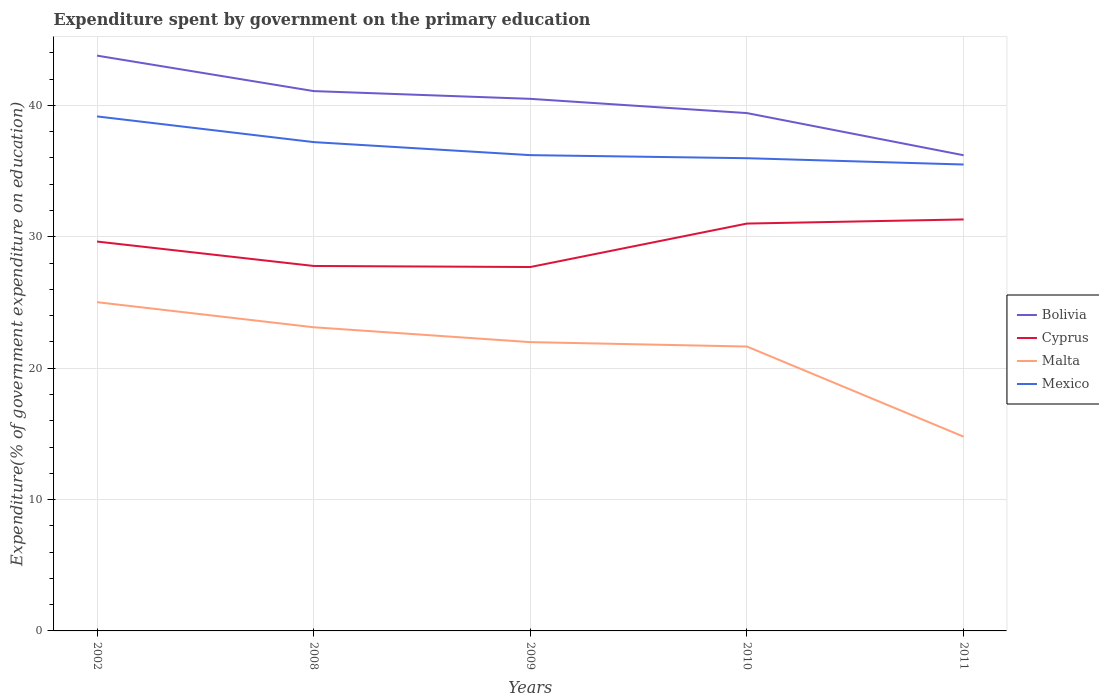Across all years, what is the maximum expenditure spent by government on the primary education in Bolivia?
Provide a short and direct response. 36.21. What is the total expenditure spent by government on the primary education in Cyprus in the graph?
Make the answer very short. -3.62. What is the difference between the highest and the second highest expenditure spent by government on the primary education in Malta?
Offer a terse response. 10.24. What is the difference between the highest and the lowest expenditure spent by government on the primary education in Malta?
Your answer should be compact. 4. How many lines are there?
Ensure brevity in your answer.  4. What is the difference between two consecutive major ticks on the Y-axis?
Give a very brief answer. 10. Does the graph contain any zero values?
Offer a very short reply. No. Does the graph contain grids?
Your answer should be very brief. Yes. Where does the legend appear in the graph?
Your response must be concise. Center right. How many legend labels are there?
Give a very brief answer. 4. What is the title of the graph?
Make the answer very short. Expenditure spent by government on the primary education. Does "Luxembourg" appear as one of the legend labels in the graph?
Offer a very short reply. No. What is the label or title of the Y-axis?
Make the answer very short. Expenditure(% of government expenditure on education). What is the Expenditure(% of government expenditure on education) in Bolivia in 2002?
Ensure brevity in your answer.  43.79. What is the Expenditure(% of government expenditure on education) of Cyprus in 2002?
Give a very brief answer. 29.64. What is the Expenditure(% of government expenditure on education) in Malta in 2002?
Your response must be concise. 25.02. What is the Expenditure(% of government expenditure on education) of Mexico in 2002?
Ensure brevity in your answer.  39.16. What is the Expenditure(% of government expenditure on education) in Bolivia in 2008?
Provide a succinct answer. 41.09. What is the Expenditure(% of government expenditure on education) of Cyprus in 2008?
Make the answer very short. 27.78. What is the Expenditure(% of government expenditure on education) of Malta in 2008?
Give a very brief answer. 23.11. What is the Expenditure(% of government expenditure on education) of Mexico in 2008?
Provide a succinct answer. 37.21. What is the Expenditure(% of government expenditure on education) in Bolivia in 2009?
Give a very brief answer. 40.5. What is the Expenditure(% of government expenditure on education) in Cyprus in 2009?
Your answer should be compact. 27.7. What is the Expenditure(% of government expenditure on education) of Malta in 2009?
Ensure brevity in your answer.  21.98. What is the Expenditure(% of government expenditure on education) in Mexico in 2009?
Make the answer very short. 36.22. What is the Expenditure(% of government expenditure on education) in Bolivia in 2010?
Your answer should be very brief. 39.42. What is the Expenditure(% of government expenditure on education) in Cyprus in 2010?
Your response must be concise. 31.01. What is the Expenditure(% of government expenditure on education) in Malta in 2010?
Your answer should be very brief. 21.65. What is the Expenditure(% of government expenditure on education) of Mexico in 2010?
Offer a terse response. 35.98. What is the Expenditure(% of government expenditure on education) of Bolivia in 2011?
Make the answer very short. 36.21. What is the Expenditure(% of government expenditure on education) in Cyprus in 2011?
Provide a short and direct response. 31.32. What is the Expenditure(% of government expenditure on education) of Malta in 2011?
Give a very brief answer. 14.79. What is the Expenditure(% of government expenditure on education) in Mexico in 2011?
Give a very brief answer. 35.5. Across all years, what is the maximum Expenditure(% of government expenditure on education) in Bolivia?
Provide a succinct answer. 43.79. Across all years, what is the maximum Expenditure(% of government expenditure on education) in Cyprus?
Your answer should be very brief. 31.32. Across all years, what is the maximum Expenditure(% of government expenditure on education) in Malta?
Offer a terse response. 25.02. Across all years, what is the maximum Expenditure(% of government expenditure on education) of Mexico?
Ensure brevity in your answer.  39.16. Across all years, what is the minimum Expenditure(% of government expenditure on education) of Bolivia?
Offer a very short reply. 36.21. Across all years, what is the minimum Expenditure(% of government expenditure on education) in Cyprus?
Your answer should be very brief. 27.7. Across all years, what is the minimum Expenditure(% of government expenditure on education) in Malta?
Offer a terse response. 14.79. Across all years, what is the minimum Expenditure(% of government expenditure on education) in Mexico?
Your answer should be compact. 35.5. What is the total Expenditure(% of government expenditure on education) in Bolivia in the graph?
Your answer should be compact. 201.01. What is the total Expenditure(% of government expenditure on education) of Cyprus in the graph?
Provide a short and direct response. 147.45. What is the total Expenditure(% of government expenditure on education) in Malta in the graph?
Your answer should be very brief. 106.56. What is the total Expenditure(% of government expenditure on education) of Mexico in the graph?
Give a very brief answer. 184.08. What is the difference between the Expenditure(% of government expenditure on education) of Cyprus in 2002 and that in 2008?
Offer a very short reply. 1.86. What is the difference between the Expenditure(% of government expenditure on education) of Malta in 2002 and that in 2008?
Provide a succinct answer. 1.91. What is the difference between the Expenditure(% of government expenditure on education) of Mexico in 2002 and that in 2008?
Give a very brief answer. 1.96. What is the difference between the Expenditure(% of government expenditure on education) of Bolivia in 2002 and that in 2009?
Provide a succinct answer. 3.29. What is the difference between the Expenditure(% of government expenditure on education) in Cyprus in 2002 and that in 2009?
Make the answer very short. 1.94. What is the difference between the Expenditure(% of government expenditure on education) of Malta in 2002 and that in 2009?
Ensure brevity in your answer.  3.04. What is the difference between the Expenditure(% of government expenditure on education) in Mexico in 2002 and that in 2009?
Your answer should be compact. 2.95. What is the difference between the Expenditure(% of government expenditure on education) in Bolivia in 2002 and that in 2010?
Ensure brevity in your answer.  4.37. What is the difference between the Expenditure(% of government expenditure on education) of Cyprus in 2002 and that in 2010?
Your answer should be compact. -1.37. What is the difference between the Expenditure(% of government expenditure on education) of Malta in 2002 and that in 2010?
Provide a succinct answer. 3.38. What is the difference between the Expenditure(% of government expenditure on education) in Mexico in 2002 and that in 2010?
Your answer should be very brief. 3.18. What is the difference between the Expenditure(% of government expenditure on education) in Bolivia in 2002 and that in 2011?
Your answer should be compact. 7.58. What is the difference between the Expenditure(% of government expenditure on education) of Cyprus in 2002 and that in 2011?
Provide a succinct answer. -1.68. What is the difference between the Expenditure(% of government expenditure on education) of Malta in 2002 and that in 2011?
Keep it short and to the point. 10.24. What is the difference between the Expenditure(% of government expenditure on education) in Mexico in 2002 and that in 2011?
Give a very brief answer. 3.66. What is the difference between the Expenditure(% of government expenditure on education) in Bolivia in 2008 and that in 2009?
Make the answer very short. 0.59. What is the difference between the Expenditure(% of government expenditure on education) in Cyprus in 2008 and that in 2009?
Your answer should be very brief. 0.08. What is the difference between the Expenditure(% of government expenditure on education) in Malta in 2008 and that in 2009?
Offer a very short reply. 1.13. What is the difference between the Expenditure(% of government expenditure on education) of Bolivia in 2008 and that in 2010?
Your answer should be compact. 1.67. What is the difference between the Expenditure(% of government expenditure on education) of Cyprus in 2008 and that in 2010?
Your answer should be compact. -3.23. What is the difference between the Expenditure(% of government expenditure on education) of Malta in 2008 and that in 2010?
Make the answer very short. 1.47. What is the difference between the Expenditure(% of government expenditure on education) in Mexico in 2008 and that in 2010?
Your answer should be very brief. 1.22. What is the difference between the Expenditure(% of government expenditure on education) in Bolivia in 2008 and that in 2011?
Ensure brevity in your answer.  4.88. What is the difference between the Expenditure(% of government expenditure on education) of Cyprus in 2008 and that in 2011?
Your answer should be compact. -3.54. What is the difference between the Expenditure(% of government expenditure on education) of Malta in 2008 and that in 2011?
Your response must be concise. 8.33. What is the difference between the Expenditure(% of government expenditure on education) of Mexico in 2008 and that in 2011?
Your answer should be compact. 1.71. What is the difference between the Expenditure(% of government expenditure on education) in Bolivia in 2009 and that in 2010?
Your answer should be very brief. 1.08. What is the difference between the Expenditure(% of government expenditure on education) of Cyprus in 2009 and that in 2010?
Your answer should be very brief. -3.31. What is the difference between the Expenditure(% of government expenditure on education) of Malta in 2009 and that in 2010?
Offer a very short reply. 0.34. What is the difference between the Expenditure(% of government expenditure on education) in Mexico in 2009 and that in 2010?
Offer a very short reply. 0.23. What is the difference between the Expenditure(% of government expenditure on education) of Bolivia in 2009 and that in 2011?
Your answer should be compact. 4.29. What is the difference between the Expenditure(% of government expenditure on education) in Cyprus in 2009 and that in 2011?
Give a very brief answer. -3.62. What is the difference between the Expenditure(% of government expenditure on education) in Malta in 2009 and that in 2011?
Your answer should be compact. 7.2. What is the difference between the Expenditure(% of government expenditure on education) of Mexico in 2009 and that in 2011?
Make the answer very short. 0.71. What is the difference between the Expenditure(% of government expenditure on education) of Bolivia in 2010 and that in 2011?
Your response must be concise. 3.21. What is the difference between the Expenditure(% of government expenditure on education) of Cyprus in 2010 and that in 2011?
Give a very brief answer. -0.31. What is the difference between the Expenditure(% of government expenditure on education) of Malta in 2010 and that in 2011?
Make the answer very short. 6.86. What is the difference between the Expenditure(% of government expenditure on education) of Mexico in 2010 and that in 2011?
Your answer should be very brief. 0.48. What is the difference between the Expenditure(% of government expenditure on education) in Bolivia in 2002 and the Expenditure(% of government expenditure on education) in Cyprus in 2008?
Keep it short and to the point. 16.01. What is the difference between the Expenditure(% of government expenditure on education) in Bolivia in 2002 and the Expenditure(% of government expenditure on education) in Malta in 2008?
Ensure brevity in your answer.  20.68. What is the difference between the Expenditure(% of government expenditure on education) of Bolivia in 2002 and the Expenditure(% of government expenditure on education) of Mexico in 2008?
Make the answer very short. 6.58. What is the difference between the Expenditure(% of government expenditure on education) of Cyprus in 2002 and the Expenditure(% of government expenditure on education) of Malta in 2008?
Make the answer very short. 6.52. What is the difference between the Expenditure(% of government expenditure on education) of Cyprus in 2002 and the Expenditure(% of government expenditure on education) of Mexico in 2008?
Ensure brevity in your answer.  -7.57. What is the difference between the Expenditure(% of government expenditure on education) of Malta in 2002 and the Expenditure(% of government expenditure on education) of Mexico in 2008?
Ensure brevity in your answer.  -12.18. What is the difference between the Expenditure(% of government expenditure on education) of Bolivia in 2002 and the Expenditure(% of government expenditure on education) of Cyprus in 2009?
Make the answer very short. 16.09. What is the difference between the Expenditure(% of government expenditure on education) of Bolivia in 2002 and the Expenditure(% of government expenditure on education) of Malta in 2009?
Keep it short and to the point. 21.81. What is the difference between the Expenditure(% of government expenditure on education) in Bolivia in 2002 and the Expenditure(% of government expenditure on education) in Mexico in 2009?
Your answer should be compact. 7.58. What is the difference between the Expenditure(% of government expenditure on education) in Cyprus in 2002 and the Expenditure(% of government expenditure on education) in Malta in 2009?
Your answer should be very brief. 7.66. What is the difference between the Expenditure(% of government expenditure on education) of Cyprus in 2002 and the Expenditure(% of government expenditure on education) of Mexico in 2009?
Offer a very short reply. -6.58. What is the difference between the Expenditure(% of government expenditure on education) in Malta in 2002 and the Expenditure(% of government expenditure on education) in Mexico in 2009?
Provide a short and direct response. -11.19. What is the difference between the Expenditure(% of government expenditure on education) of Bolivia in 2002 and the Expenditure(% of government expenditure on education) of Cyprus in 2010?
Your answer should be very brief. 12.78. What is the difference between the Expenditure(% of government expenditure on education) of Bolivia in 2002 and the Expenditure(% of government expenditure on education) of Malta in 2010?
Offer a terse response. 22.14. What is the difference between the Expenditure(% of government expenditure on education) of Bolivia in 2002 and the Expenditure(% of government expenditure on education) of Mexico in 2010?
Ensure brevity in your answer.  7.81. What is the difference between the Expenditure(% of government expenditure on education) of Cyprus in 2002 and the Expenditure(% of government expenditure on education) of Malta in 2010?
Make the answer very short. 7.99. What is the difference between the Expenditure(% of government expenditure on education) in Cyprus in 2002 and the Expenditure(% of government expenditure on education) in Mexico in 2010?
Provide a succinct answer. -6.34. What is the difference between the Expenditure(% of government expenditure on education) in Malta in 2002 and the Expenditure(% of government expenditure on education) in Mexico in 2010?
Your answer should be compact. -10.96. What is the difference between the Expenditure(% of government expenditure on education) in Bolivia in 2002 and the Expenditure(% of government expenditure on education) in Cyprus in 2011?
Your answer should be very brief. 12.47. What is the difference between the Expenditure(% of government expenditure on education) in Bolivia in 2002 and the Expenditure(% of government expenditure on education) in Malta in 2011?
Make the answer very short. 29. What is the difference between the Expenditure(% of government expenditure on education) of Bolivia in 2002 and the Expenditure(% of government expenditure on education) of Mexico in 2011?
Ensure brevity in your answer.  8.29. What is the difference between the Expenditure(% of government expenditure on education) in Cyprus in 2002 and the Expenditure(% of government expenditure on education) in Malta in 2011?
Your answer should be compact. 14.85. What is the difference between the Expenditure(% of government expenditure on education) of Cyprus in 2002 and the Expenditure(% of government expenditure on education) of Mexico in 2011?
Make the answer very short. -5.86. What is the difference between the Expenditure(% of government expenditure on education) in Malta in 2002 and the Expenditure(% of government expenditure on education) in Mexico in 2011?
Provide a succinct answer. -10.48. What is the difference between the Expenditure(% of government expenditure on education) of Bolivia in 2008 and the Expenditure(% of government expenditure on education) of Cyprus in 2009?
Ensure brevity in your answer.  13.39. What is the difference between the Expenditure(% of government expenditure on education) of Bolivia in 2008 and the Expenditure(% of government expenditure on education) of Malta in 2009?
Ensure brevity in your answer.  19.11. What is the difference between the Expenditure(% of government expenditure on education) in Bolivia in 2008 and the Expenditure(% of government expenditure on education) in Mexico in 2009?
Offer a very short reply. 4.88. What is the difference between the Expenditure(% of government expenditure on education) of Cyprus in 2008 and the Expenditure(% of government expenditure on education) of Malta in 2009?
Give a very brief answer. 5.8. What is the difference between the Expenditure(% of government expenditure on education) in Cyprus in 2008 and the Expenditure(% of government expenditure on education) in Mexico in 2009?
Provide a succinct answer. -8.44. What is the difference between the Expenditure(% of government expenditure on education) of Malta in 2008 and the Expenditure(% of government expenditure on education) of Mexico in 2009?
Offer a very short reply. -13.1. What is the difference between the Expenditure(% of government expenditure on education) in Bolivia in 2008 and the Expenditure(% of government expenditure on education) in Cyprus in 2010?
Keep it short and to the point. 10.08. What is the difference between the Expenditure(% of government expenditure on education) of Bolivia in 2008 and the Expenditure(% of government expenditure on education) of Malta in 2010?
Offer a terse response. 19.44. What is the difference between the Expenditure(% of government expenditure on education) of Bolivia in 2008 and the Expenditure(% of government expenditure on education) of Mexico in 2010?
Make the answer very short. 5.11. What is the difference between the Expenditure(% of government expenditure on education) of Cyprus in 2008 and the Expenditure(% of government expenditure on education) of Malta in 2010?
Provide a short and direct response. 6.13. What is the difference between the Expenditure(% of government expenditure on education) in Cyprus in 2008 and the Expenditure(% of government expenditure on education) in Mexico in 2010?
Provide a succinct answer. -8.2. What is the difference between the Expenditure(% of government expenditure on education) of Malta in 2008 and the Expenditure(% of government expenditure on education) of Mexico in 2010?
Your response must be concise. -12.87. What is the difference between the Expenditure(% of government expenditure on education) in Bolivia in 2008 and the Expenditure(% of government expenditure on education) in Cyprus in 2011?
Ensure brevity in your answer.  9.77. What is the difference between the Expenditure(% of government expenditure on education) in Bolivia in 2008 and the Expenditure(% of government expenditure on education) in Malta in 2011?
Provide a short and direct response. 26.3. What is the difference between the Expenditure(% of government expenditure on education) in Bolivia in 2008 and the Expenditure(% of government expenditure on education) in Mexico in 2011?
Offer a very short reply. 5.59. What is the difference between the Expenditure(% of government expenditure on education) in Cyprus in 2008 and the Expenditure(% of government expenditure on education) in Malta in 2011?
Provide a succinct answer. 12.99. What is the difference between the Expenditure(% of government expenditure on education) of Cyprus in 2008 and the Expenditure(% of government expenditure on education) of Mexico in 2011?
Provide a short and direct response. -7.72. What is the difference between the Expenditure(% of government expenditure on education) in Malta in 2008 and the Expenditure(% of government expenditure on education) in Mexico in 2011?
Offer a terse response. -12.39. What is the difference between the Expenditure(% of government expenditure on education) of Bolivia in 2009 and the Expenditure(% of government expenditure on education) of Cyprus in 2010?
Offer a very short reply. 9.49. What is the difference between the Expenditure(% of government expenditure on education) in Bolivia in 2009 and the Expenditure(% of government expenditure on education) in Malta in 2010?
Keep it short and to the point. 18.85. What is the difference between the Expenditure(% of government expenditure on education) of Bolivia in 2009 and the Expenditure(% of government expenditure on education) of Mexico in 2010?
Your answer should be compact. 4.52. What is the difference between the Expenditure(% of government expenditure on education) in Cyprus in 2009 and the Expenditure(% of government expenditure on education) in Malta in 2010?
Your answer should be very brief. 6.05. What is the difference between the Expenditure(% of government expenditure on education) of Cyprus in 2009 and the Expenditure(% of government expenditure on education) of Mexico in 2010?
Give a very brief answer. -8.28. What is the difference between the Expenditure(% of government expenditure on education) of Malta in 2009 and the Expenditure(% of government expenditure on education) of Mexico in 2010?
Provide a succinct answer. -14. What is the difference between the Expenditure(% of government expenditure on education) in Bolivia in 2009 and the Expenditure(% of government expenditure on education) in Cyprus in 2011?
Keep it short and to the point. 9.18. What is the difference between the Expenditure(% of government expenditure on education) in Bolivia in 2009 and the Expenditure(% of government expenditure on education) in Malta in 2011?
Offer a very short reply. 25.71. What is the difference between the Expenditure(% of government expenditure on education) of Bolivia in 2009 and the Expenditure(% of government expenditure on education) of Mexico in 2011?
Offer a very short reply. 5. What is the difference between the Expenditure(% of government expenditure on education) of Cyprus in 2009 and the Expenditure(% of government expenditure on education) of Malta in 2011?
Offer a very short reply. 12.91. What is the difference between the Expenditure(% of government expenditure on education) of Cyprus in 2009 and the Expenditure(% of government expenditure on education) of Mexico in 2011?
Make the answer very short. -7.8. What is the difference between the Expenditure(% of government expenditure on education) of Malta in 2009 and the Expenditure(% of government expenditure on education) of Mexico in 2011?
Provide a succinct answer. -13.52. What is the difference between the Expenditure(% of government expenditure on education) in Bolivia in 2010 and the Expenditure(% of government expenditure on education) in Cyprus in 2011?
Your answer should be very brief. 8.1. What is the difference between the Expenditure(% of government expenditure on education) in Bolivia in 2010 and the Expenditure(% of government expenditure on education) in Malta in 2011?
Offer a very short reply. 24.63. What is the difference between the Expenditure(% of government expenditure on education) of Bolivia in 2010 and the Expenditure(% of government expenditure on education) of Mexico in 2011?
Ensure brevity in your answer.  3.92. What is the difference between the Expenditure(% of government expenditure on education) of Cyprus in 2010 and the Expenditure(% of government expenditure on education) of Malta in 2011?
Provide a short and direct response. 16.22. What is the difference between the Expenditure(% of government expenditure on education) of Cyprus in 2010 and the Expenditure(% of government expenditure on education) of Mexico in 2011?
Offer a very short reply. -4.49. What is the difference between the Expenditure(% of government expenditure on education) of Malta in 2010 and the Expenditure(% of government expenditure on education) of Mexico in 2011?
Give a very brief answer. -13.85. What is the average Expenditure(% of government expenditure on education) of Bolivia per year?
Your answer should be very brief. 40.2. What is the average Expenditure(% of government expenditure on education) of Cyprus per year?
Offer a very short reply. 29.49. What is the average Expenditure(% of government expenditure on education) in Malta per year?
Provide a succinct answer. 21.31. What is the average Expenditure(% of government expenditure on education) in Mexico per year?
Your answer should be very brief. 36.82. In the year 2002, what is the difference between the Expenditure(% of government expenditure on education) of Bolivia and Expenditure(% of government expenditure on education) of Cyprus?
Your answer should be very brief. 14.15. In the year 2002, what is the difference between the Expenditure(% of government expenditure on education) of Bolivia and Expenditure(% of government expenditure on education) of Malta?
Offer a terse response. 18.77. In the year 2002, what is the difference between the Expenditure(% of government expenditure on education) in Bolivia and Expenditure(% of government expenditure on education) in Mexico?
Provide a succinct answer. 4.63. In the year 2002, what is the difference between the Expenditure(% of government expenditure on education) in Cyprus and Expenditure(% of government expenditure on education) in Malta?
Offer a very short reply. 4.62. In the year 2002, what is the difference between the Expenditure(% of government expenditure on education) in Cyprus and Expenditure(% of government expenditure on education) in Mexico?
Give a very brief answer. -9.53. In the year 2002, what is the difference between the Expenditure(% of government expenditure on education) of Malta and Expenditure(% of government expenditure on education) of Mexico?
Provide a short and direct response. -14.14. In the year 2008, what is the difference between the Expenditure(% of government expenditure on education) in Bolivia and Expenditure(% of government expenditure on education) in Cyprus?
Provide a short and direct response. 13.31. In the year 2008, what is the difference between the Expenditure(% of government expenditure on education) in Bolivia and Expenditure(% of government expenditure on education) in Malta?
Your answer should be compact. 17.98. In the year 2008, what is the difference between the Expenditure(% of government expenditure on education) in Bolivia and Expenditure(% of government expenditure on education) in Mexico?
Your answer should be very brief. 3.88. In the year 2008, what is the difference between the Expenditure(% of government expenditure on education) in Cyprus and Expenditure(% of government expenditure on education) in Malta?
Make the answer very short. 4.67. In the year 2008, what is the difference between the Expenditure(% of government expenditure on education) in Cyprus and Expenditure(% of government expenditure on education) in Mexico?
Give a very brief answer. -9.43. In the year 2008, what is the difference between the Expenditure(% of government expenditure on education) in Malta and Expenditure(% of government expenditure on education) in Mexico?
Your answer should be very brief. -14.09. In the year 2009, what is the difference between the Expenditure(% of government expenditure on education) in Bolivia and Expenditure(% of government expenditure on education) in Cyprus?
Keep it short and to the point. 12.8. In the year 2009, what is the difference between the Expenditure(% of government expenditure on education) in Bolivia and Expenditure(% of government expenditure on education) in Malta?
Offer a very short reply. 18.52. In the year 2009, what is the difference between the Expenditure(% of government expenditure on education) of Bolivia and Expenditure(% of government expenditure on education) of Mexico?
Provide a short and direct response. 4.29. In the year 2009, what is the difference between the Expenditure(% of government expenditure on education) of Cyprus and Expenditure(% of government expenditure on education) of Malta?
Ensure brevity in your answer.  5.72. In the year 2009, what is the difference between the Expenditure(% of government expenditure on education) in Cyprus and Expenditure(% of government expenditure on education) in Mexico?
Provide a short and direct response. -8.52. In the year 2009, what is the difference between the Expenditure(% of government expenditure on education) of Malta and Expenditure(% of government expenditure on education) of Mexico?
Your response must be concise. -14.23. In the year 2010, what is the difference between the Expenditure(% of government expenditure on education) of Bolivia and Expenditure(% of government expenditure on education) of Cyprus?
Your response must be concise. 8.41. In the year 2010, what is the difference between the Expenditure(% of government expenditure on education) of Bolivia and Expenditure(% of government expenditure on education) of Malta?
Keep it short and to the point. 17.77. In the year 2010, what is the difference between the Expenditure(% of government expenditure on education) in Bolivia and Expenditure(% of government expenditure on education) in Mexico?
Provide a succinct answer. 3.43. In the year 2010, what is the difference between the Expenditure(% of government expenditure on education) in Cyprus and Expenditure(% of government expenditure on education) in Malta?
Offer a terse response. 9.36. In the year 2010, what is the difference between the Expenditure(% of government expenditure on education) in Cyprus and Expenditure(% of government expenditure on education) in Mexico?
Provide a short and direct response. -4.98. In the year 2010, what is the difference between the Expenditure(% of government expenditure on education) of Malta and Expenditure(% of government expenditure on education) of Mexico?
Provide a short and direct response. -14.34. In the year 2011, what is the difference between the Expenditure(% of government expenditure on education) in Bolivia and Expenditure(% of government expenditure on education) in Cyprus?
Offer a very short reply. 4.89. In the year 2011, what is the difference between the Expenditure(% of government expenditure on education) of Bolivia and Expenditure(% of government expenditure on education) of Malta?
Provide a succinct answer. 21.42. In the year 2011, what is the difference between the Expenditure(% of government expenditure on education) in Bolivia and Expenditure(% of government expenditure on education) in Mexico?
Provide a short and direct response. 0.71. In the year 2011, what is the difference between the Expenditure(% of government expenditure on education) in Cyprus and Expenditure(% of government expenditure on education) in Malta?
Keep it short and to the point. 16.53. In the year 2011, what is the difference between the Expenditure(% of government expenditure on education) in Cyprus and Expenditure(% of government expenditure on education) in Mexico?
Provide a short and direct response. -4.18. In the year 2011, what is the difference between the Expenditure(% of government expenditure on education) in Malta and Expenditure(% of government expenditure on education) in Mexico?
Your response must be concise. -20.71. What is the ratio of the Expenditure(% of government expenditure on education) in Bolivia in 2002 to that in 2008?
Ensure brevity in your answer.  1.07. What is the ratio of the Expenditure(% of government expenditure on education) in Cyprus in 2002 to that in 2008?
Give a very brief answer. 1.07. What is the ratio of the Expenditure(% of government expenditure on education) of Malta in 2002 to that in 2008?
Offer a very short reply. 1.08. What is the ratio of the Expenditure(% of government expenditure on education) in Mexico in 2002 to that in 2008?
Make the answer very short. 1.05. What is the ratio of the Expenditure(% of government expenditure on education) of Bolivia in 2002 to that in 2009?
Offer a terse response. 1.08. What is the ratio of the Expenditure(% of government expenditure on education) of Cyprus in 2002 to that in 2009?
Your answer should be compact. 1.07. What is the ratio of the Expenditure(% of government expenditure on education) of Malta in 2002 to that in 2009?
Ensure brevity in your answer.  1.14. What is the ratio of the Expenditure(% of government expenditure on education) in Mexico in 2002 to that in 2009?
Your answer should be compact. 1.08. What is the ratio of the Expenditure(% of government expenditure on education) of Bolivia in 2002 to that in 2010?
Your answer should be very brief. 1.11. What is the ratio of the Expenditure(% of government expenditure on education) in Cyprus in 2002 to that in 2010?
Ensure brevity in your answer.  0.96. What is the ratio of the Expenditure(% of government expenditure on education) of Malta in 2002 to that in 2010?
Provide a short and direct response. 1.16. What is the ratio of the Expenditure(% of government expenditure on education) in Mexico in 2002 to that in 2010?
Provide a short and direct response. 1.09. What is the ratio of the Expenditure(% of government expenditure on education) of Bolivia in 2002 to that in 2011?
Offer a terse response. 1.21. What is the ratio of the Expenditure(% of government expenditure on education) in Cyprus in 2002 to that in 2011?
Provide a short and direct response. 0.95. What is the ratio of the Expenditure(% of government expenditure on education) in Malta in 2002 to that in 2011?
Keep it short and to the point. 1.69. What is the ratio of the Expenditure(% of government expenditure on education) of Mexico in 2002 to that in 2011?
Provide a succinct answer. 1.1. What is the ratio of the Expenditure(% of government expenditure on education) in Bolivia in 2008 to that in 2009?
Offer a very short reply. 1.01. What is the ratio of the Expenditure(% of government expenditure on education) in Malta in 2008 to that in 2009?
Offer a very short reply. 1.05. What is the ratio of the Expenditure(% of government expenditure on education) of Mexico in 2008 to that in 2009?
Provide a short and direct response. 1.03. What is the ratio of the Expenditure(% of government expenditure on education) of Bolivia in 2008 to that in 2010?
Your response must be concise. 1.04. What is the ratio of the Expenditure(% of government expenditure on education) in Cyprus in 2008 to that in 2010?
Keep it short and to the point. 0.9. What is the ratio of the Expenditure(% of government expenditure on education) in Malta in 2008 to that in 2010?
Offer a very short reply. 1.07. What is the ratio of the Expenditure(% of government expenditure on education) of Mexico in 2008 to that in 2010?
Offer a very short reply. 1.03. What is the ratio of the Expenditure(% of government expenditure on education) of Bolivia in 2008 to that in 2011?
Your answer should be very brief. 1.13. What is the ratio of the Expenditure(% of government expenditure on education) of Cyprus in 2008 to that in 2011?
Your answer should be very brief. 0.89. What is the ratio of the Expenditure(% of government expenditure on education) of Malta in 2008 to that in 2011?
Keep it short and to the point. 1.56. What is the ratio of the Expenditure(% of government expenditure on education) in Mexico in 2008 to that in 2011?
Give a very brief answer. 1.05. What is the ratio of the Expenditure(% of government expenditure on education) in Bolivia in 2009 to that in 2010?
Offer a terse response. 1.03. What is the ratio of the Expenditure(% of government expenditure on education) of Cyprus in 2009 to that in 2010?
Give a very brief answer. 0.89. What is the ratio of the Expenditure(% of government expenditure on education) in Malta in 2009 to that in 2010?
Give a very brief answer. 1.02. What is the ratio of the Expenditure(% of government expenditure on education) of Bolivia in 2009 to that in 2011?
Give a very brief answer. 1.12. What is the ratio of the Expenditure(% of government expenditure on education) of Cyprus in 2009 to that in 2011?
Your answer should be very brief. 0.88. What is the ratio of the Expenditure(% of government expenditure on education) of Malta in 2009 to that in 2011?
Keep it short and to the point. 1.49. What is the ratio of the Expenditure(% of government expenditure on education) in Mexico in 2009 to that in 2011?
Your response must be concise. 1.02. What is the ratio of the Expenditure(% of government expenditure on education) in Bolivia in 2010 to that in 2011?
Keep it short and to the point. 1.09. What is the ratio of the Expenditure(% of government expenditure on education) in Cyprus in 2010 to that in 2011?
Your answer should be very brief. 0.99. What is the ratio of the Expenditure(% of government expenditure on education) in Malta in 2010 to that in 2011?
Offer a terse response. 1.46. What is the ratio of the Expenditure(% of government expenditure on education) in Mexico in 2010 to that in 2011?
Your response must be concise. 1.01. What is the difference between the highest and the second highest Expenditure(% of government expenditure on education) of Cyprus?
Provide a short and direct response. 0.31. What is the difference between the highest and the second highest Expenditure(% of government expenditure on education) of Malta?
Your response must be concise. 1.91. What is the difference between the highest and the second highest Expenditure(% of government expenditure on education) of Mexico?
Make the answer very short. 1.96. What is the difference between the highest and the lowest Expenditure(% of government expenditure on education) in Bolivia?
Keep it short and to the point. 7.58. What is the difference between the highest and the lowest Expenditure(% of government expenditure on education) in Cyprus?
Your answer should be compact. 3.62. What is the difference between the highest and the lowest Expenditure(% of government expenditure on education) of Malta?
Your answer should be very brief. 10.24. What is the difference between the highest and the lowest Expenditure(% of government expenditure on education) of Mexico?
Offer a very short reply. 3.66. 